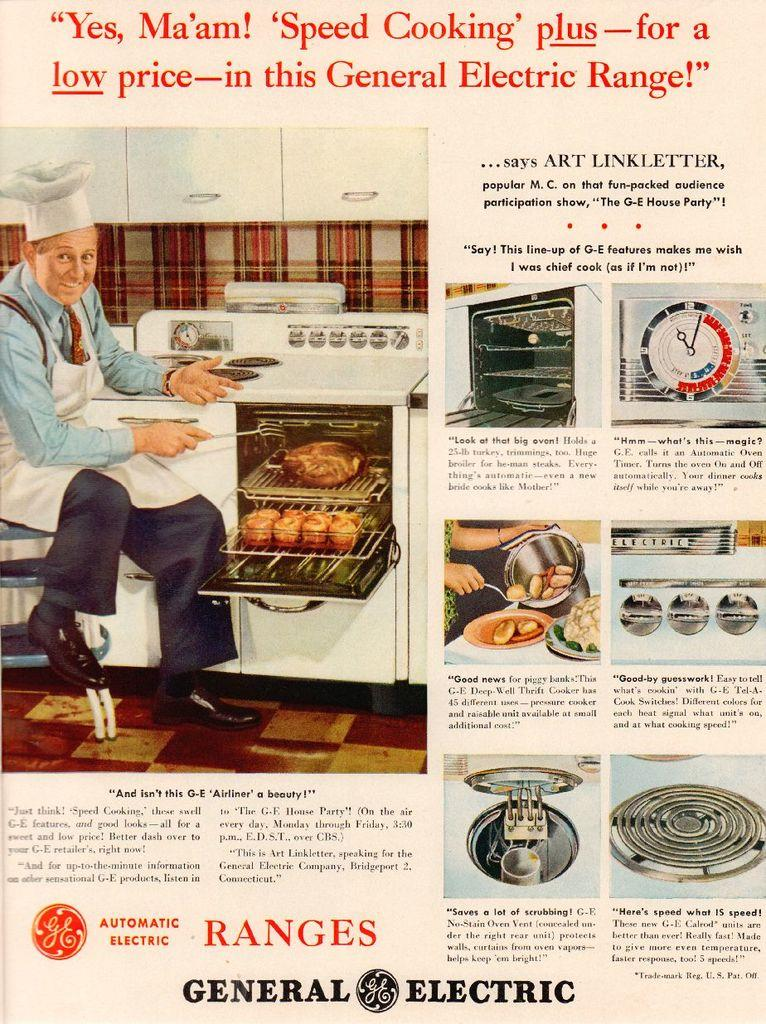<image>
Share a concise interpretation of the image provided. An old magazine Ad for a General Electric oven. 